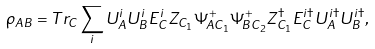<formula> <loc_0><loc_0><loc_500><loc_500>\rho _ { A B } = T r _ { C } \sum _ { i } U _ { A } ^ { i } U _ { B } ^ { i } E _ { C } ^ { i } Z _ { C _ { 1 } } \Psi ^ { + } _ { A C _ { 1 } } \Psi ^ { + } _ { B C _ { 2 } } Z _ { C _ { 1 } } ^ { \dag } E _ { C } ^ { i \dag } U _ { A } ^ { i \dag } U _ { B } ^ { i \dag } ,</formula> 